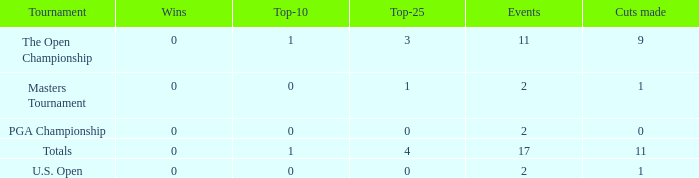What is his low win total when he has over 3 top 25s and under 9 cuts made? None. 